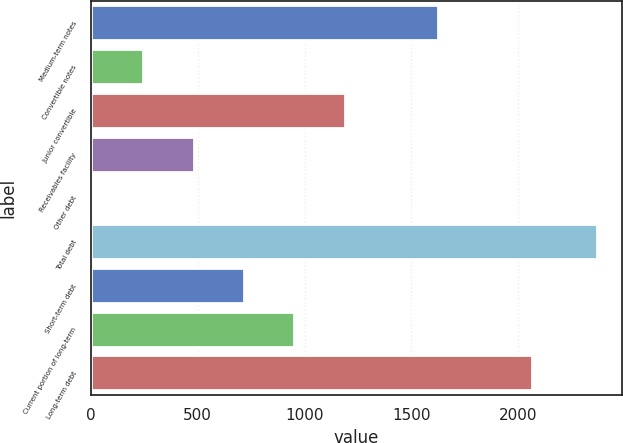Convert chart. <chart><loc_0><loc_0><loc_500><loc_500><bar_chart><fcel>Medium-term notes<fcel>Convertible notes<fcel>Junior convertible<fcel>Receivables facility<fcel>Other debt<fcel>Total debt<fcel>Short-term debt<fcel>Current portion of long-term<fcel>Long-term debt<nl><fcel>1623<fcel>243.82<fcel>1188.3<fcel>479.94<fcel>7.7<fcel>2368.9<fcel>716.06<fcel>952.18<fcel>2063.9<nl></chart> 